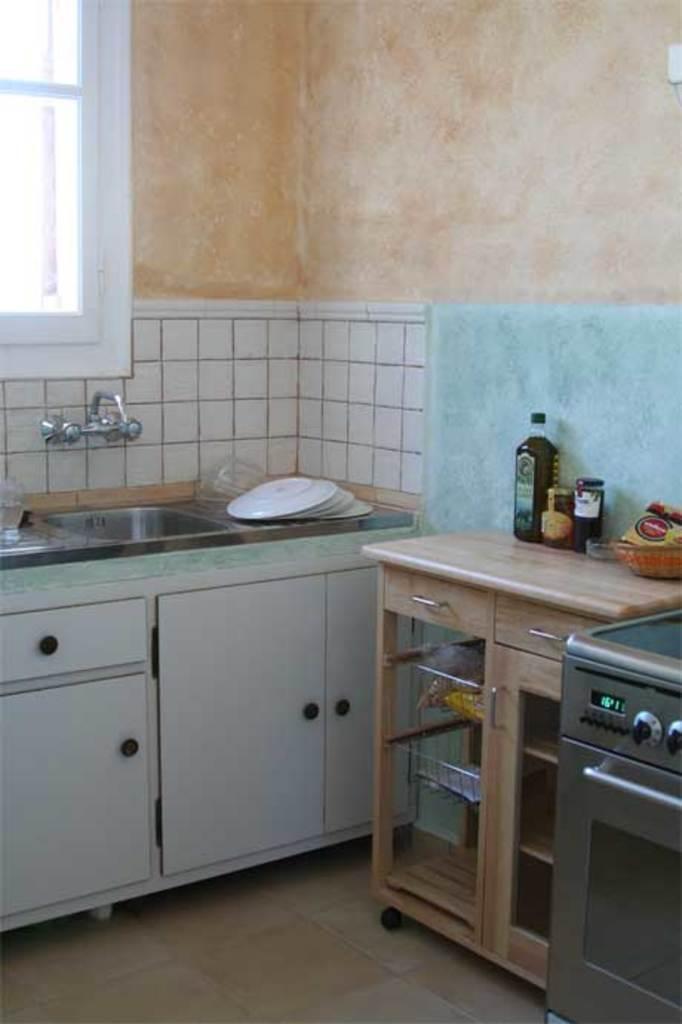Could you give a brief overview of what you see in this image? In this picture there is a image of kitchen, where the plates are kept on the floor near the sink and there is a glass window at the top of the image and the two taps near the sink and there is a basket containing the wrappers of spices and a bottle of sauce on the wooden desk. 